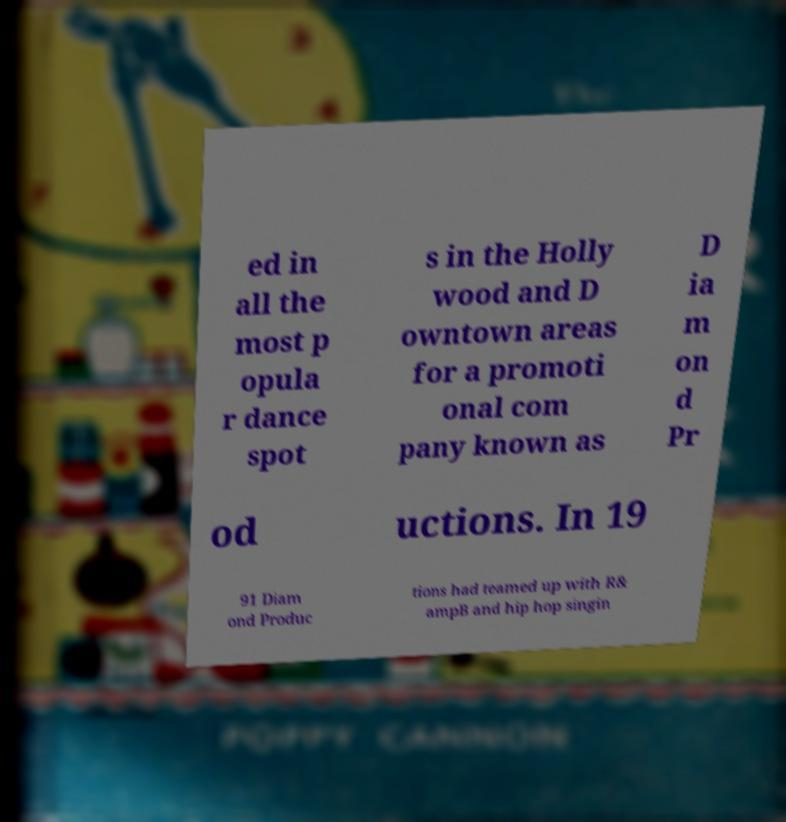Can you read and provide the text displayed in the image?This photo seems to have some interesting text. Can you extract and type it out for me? ed in all the most p opula r dance spot s in the Holly wood and D owntown areas for a promoti onal com pany known as D ia m on d Pr od uctions. In 19 91 Diam ond Produc tions had teamed up with R& ampB and hip hop singin 